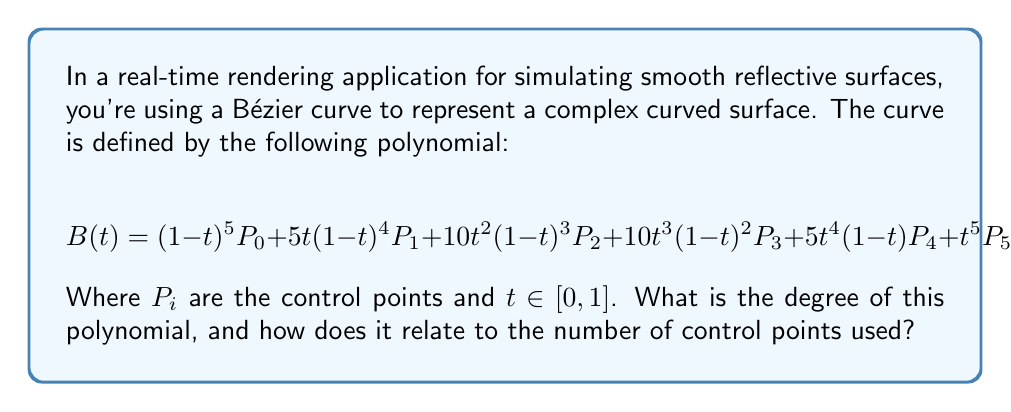Could you help me with this problem? To determine the degree of the polynomial used in this Bézier curve, we need to analyze its structure:

1. First, observe that the highest power of $t$ in the equation is 5, which appears in the last term $t^5P_5$.

2. The polynomial is in Bernstein form, which is typical for Bézier curves. The general form of a Bézier curve of degree $n$ is:

   $$ B(t) = \sum_{i=0}^n \binom{n}{i} t^i (1-t)^{n-i} P_i $$

3. In our case, we have terms from $(1-t)^5$ to $t^5$, which corresponds to $i$ ranging from 0 to 5.

4. The number of terms in a Bézier curve polynomial is always one more than its degree. Here, we have 6 terms (from $P_0$ to $P_5$).

5. Therefore, the degree of this polynomial is 5.

6. The relationship between the degree and the number of control points is:
   
   Number of control points = Degree + 1

   In this case: 6 control points = 5th degree + 1

This higher degree allows for more complex and smooth curves, which is beneficial for rendering realistic reflective surfaces in computer graphics.
Answer: The degree of the polynomial is 5, and it relates to the number of control points by the formula: Number of control points = Degree + 1. 